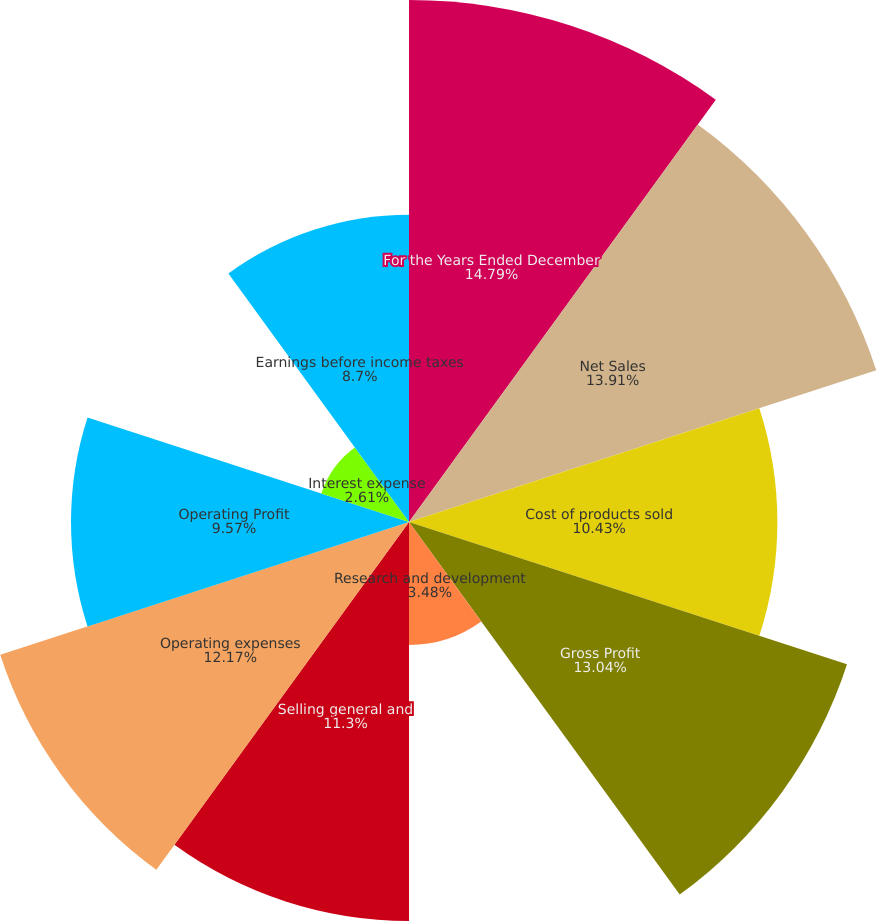Convert chart to OTSL. <chart><loc_0><loc_0><loc_500><loc_500><pie_chart><fcel>For the Years Ended December<fcel>Net Sales<fcel>Cost of products sold<fcel>Gross Profit<fcel>Research and development<fcel>Selling general and<fcel>Operating expenses<fcel>Operating Profit<fcel>Interest expense<fcel>Earnings before income taxes<nl><fcel>14.78%<fcel>13.91%<fcel>10.43%<fcel>13.04%<fcel>3.48%<fcel>11.3%<fcel>12.17%<fcel>9.57%<fcel>2.61%<fcel>8.7%<nl></chart> 